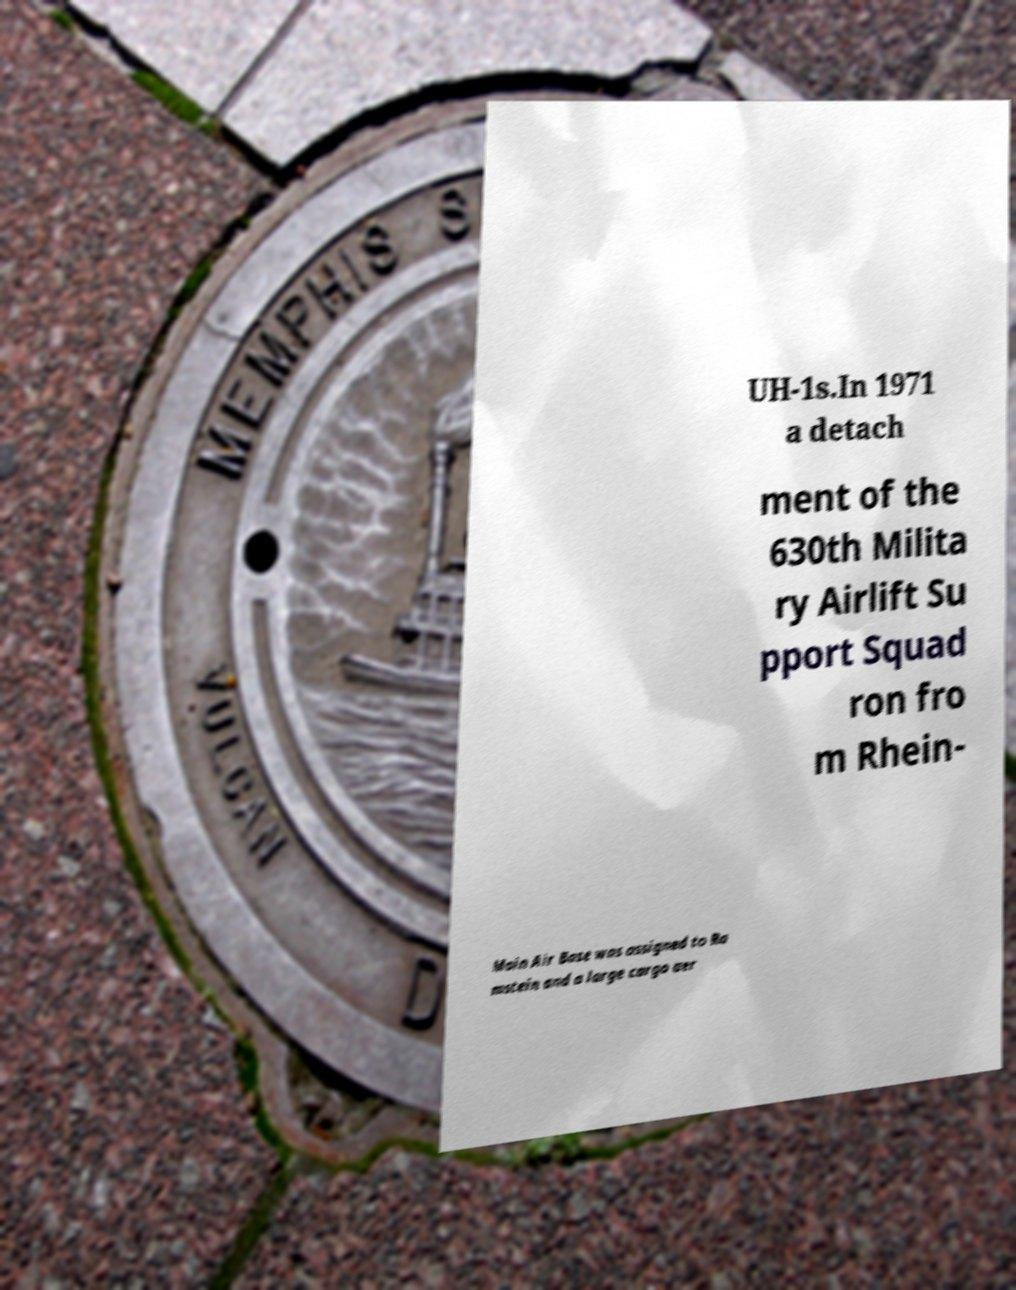What messages or text are displayed in this image? I need them in a readable, typed format. UH-1s.In 1971 a detach ment of the 630th Milita ry Airlift Su pport Squad ron fro m Rhein- Main Air Base was assigned to Ra mstein and a large cargo aer 